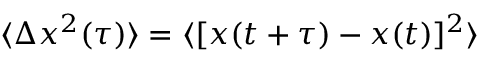<formula> <loc_0><loc_0><loc_500><loc_500>\langle \Delta x ^ { 2 } ( \tau ) \rangle = \langle [ x ( t + \tau ) - x ( t ) ] ^ { 2 } \rangle</formula> 